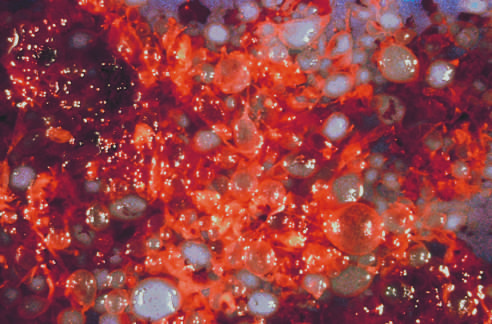does the complete hydatidiform mole consist of numerous swollen villi?
Answer the question using a single word or phrase. Yes 